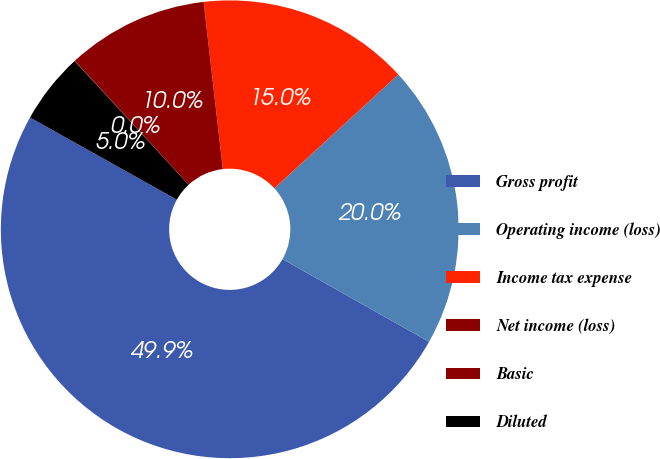Convert chart to OTSL. <chart><loc_0><loc_0><loc_500><loc_500><pie_chart><fcel>Gross profit<fcel>Operating income (loss)<fcel>Income tax expense<fcel>Net income (loss)<fcel>Basic<fcel>Diluted<nl><fcel>49.95%<fcel>20.0%<fcel>15.0%<fcel>10.01%<fcel>0.03%<fcel>5.02%<nl></chart> 